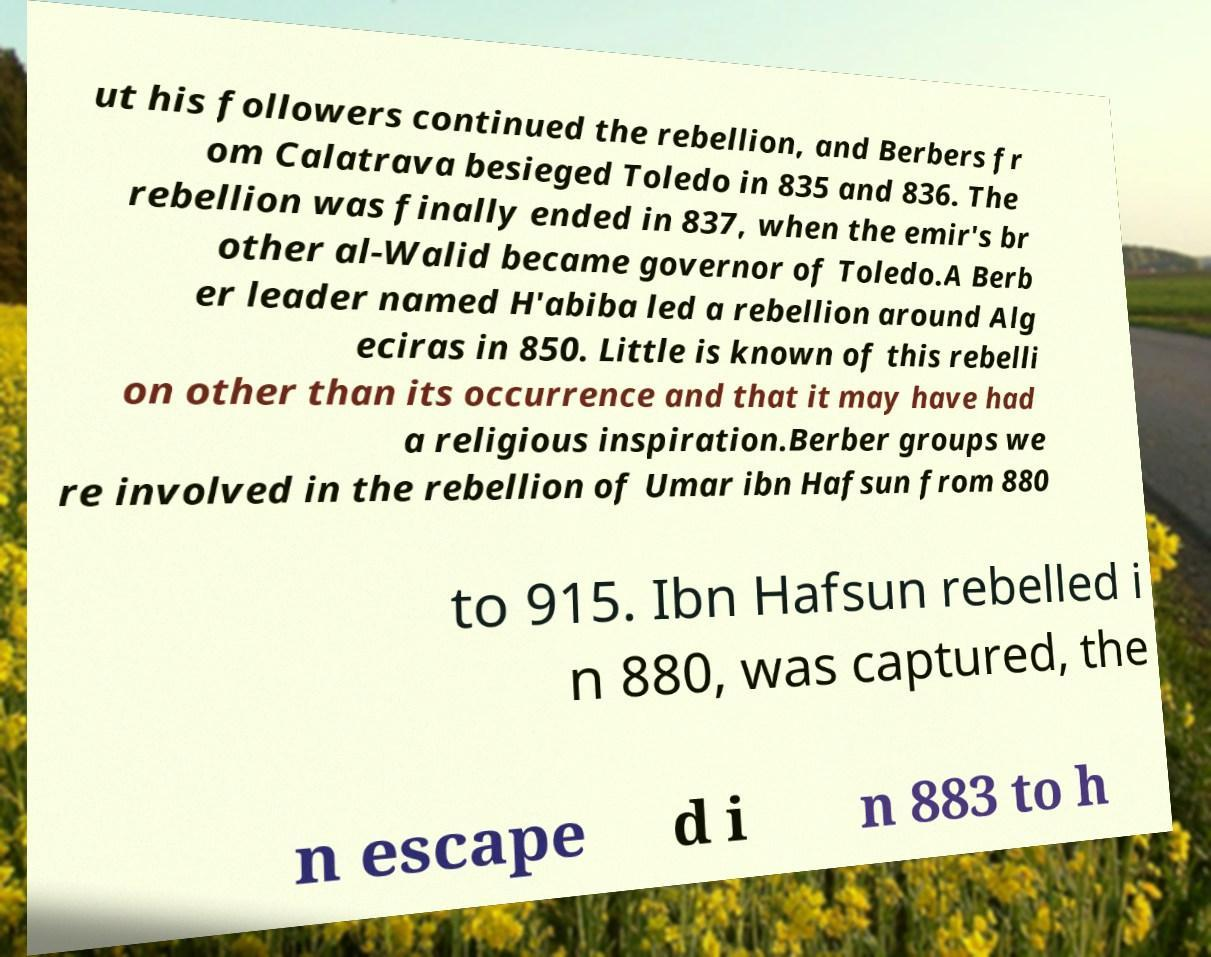Can you accurately transcribe the text from the provided image for me? ut his followers continued the rebellion, and Berbers fr om Calatrava besieged Toledo in 835 and 836. The rebellion was finally ended in 837, when the emir's br other al-Walid became governor of Toledo.A Berb er leader named H'abiba led a rebellion around Alg eciras in 850. Little is known of this rebelli on other than its occurrence and that it may have had a religious inspiration.Berber groups we re involved in the rebellion of Umar ibn Hafsun from 880 to 915. Ibn Hafsun rebelled i n 880, was captured, the n escape d i n 883 to h 